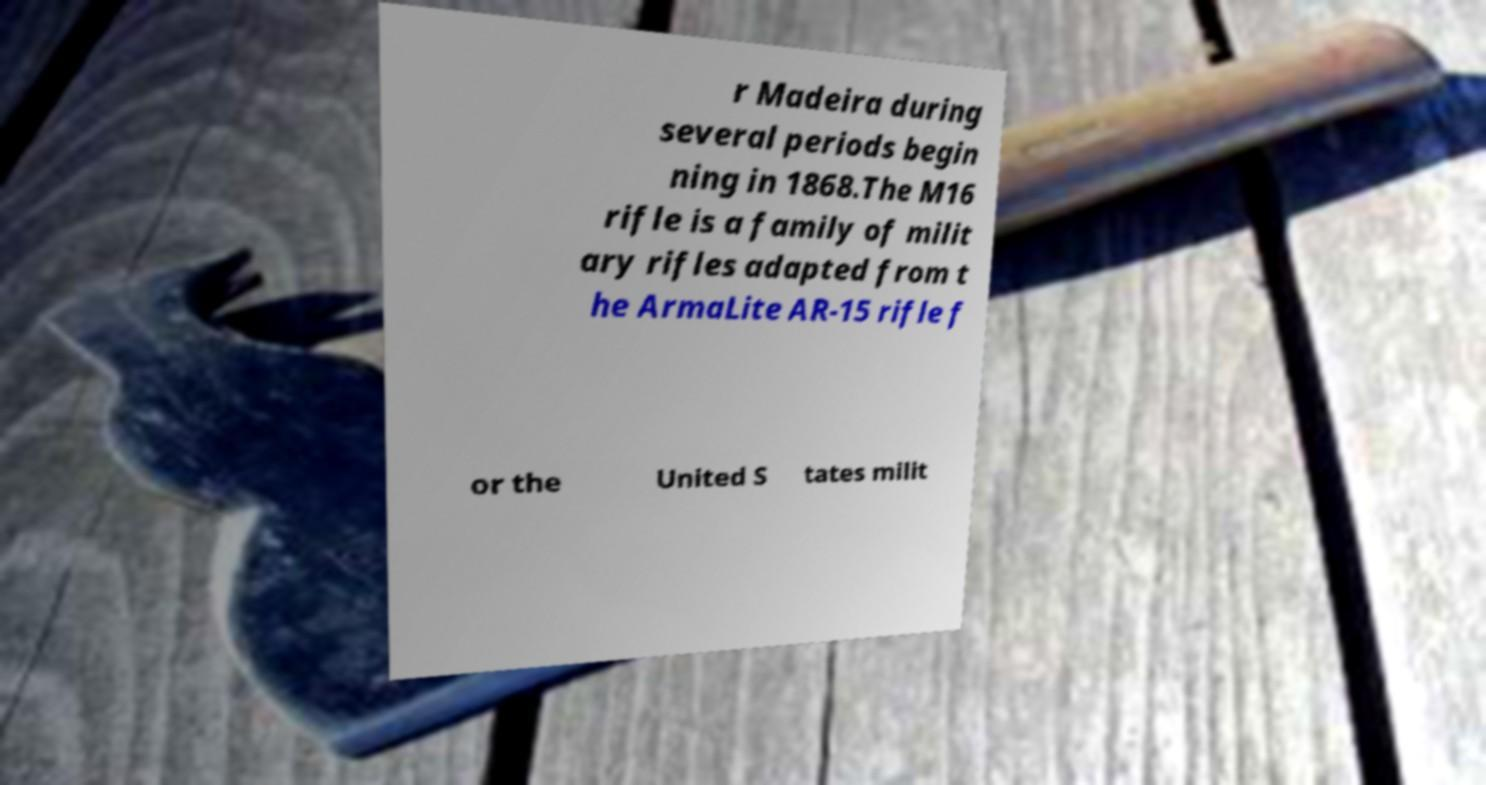Could you assist in decoding the text presented in this image and type it out clearly? r Madeira during several periods begin ning in 1868.The M16 rifle is a family of milit ary rifles adapted from t he ArmaLite AR-15 rifle f or the United S tates milit 